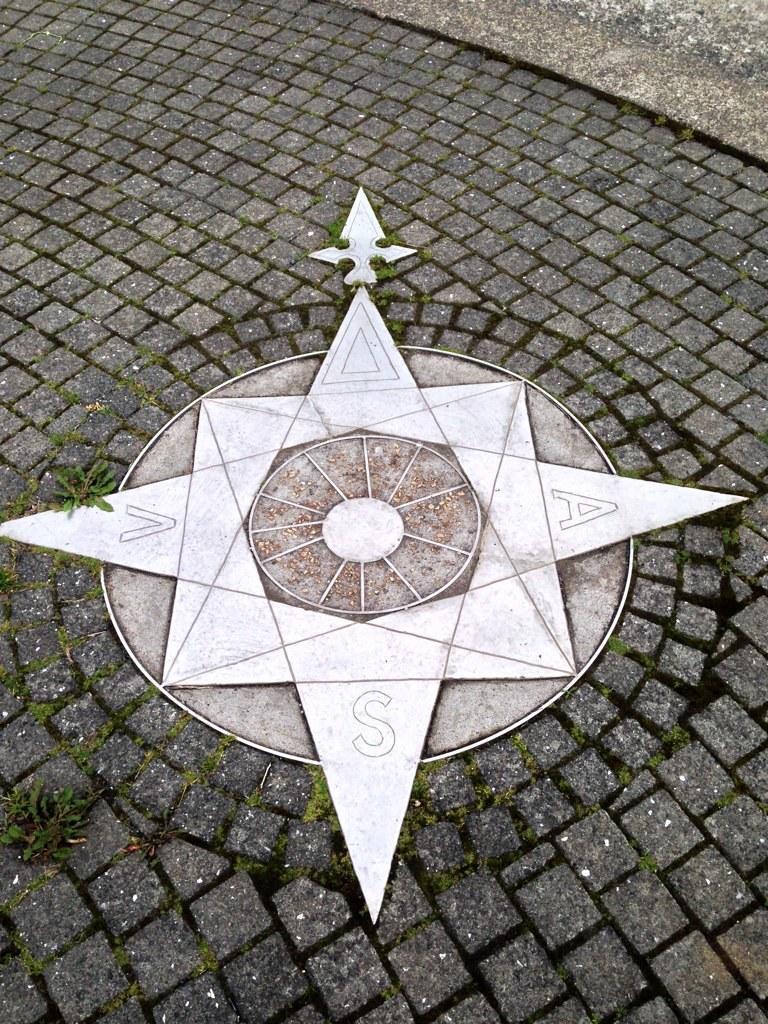Describe this image in one or two sentences. In this image I can see an object on the ground and the object is in white color. I can also see few small plants in green color. 